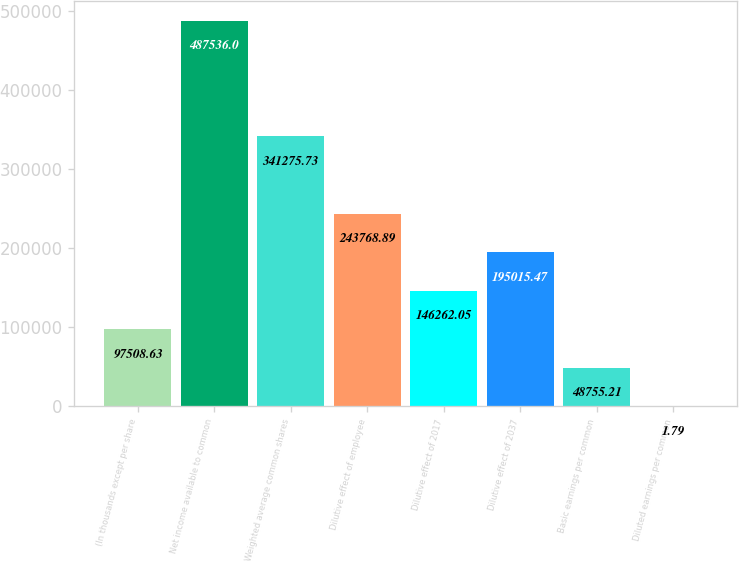Convert chart. <chart><loc_0><loc_0><loc_500><loc_500><bar_chart><fcel>(In thousands except per share<fcel>Net income available to common<fcel>Weighted average common shares<fcel>Dilutive effect of employee<fcel>Dilutive effect of 2017<fcel>Dilutive effect of 2037<fcel>Basic earnings per common<fcel>Diluted earnings per common<nl><fcel>97508.6<fcel>487536<fcel>341276<fcel>243769<fcel>146262<fcel>195015<fcel>48755.2<fcel>1.79<nl></chart> 